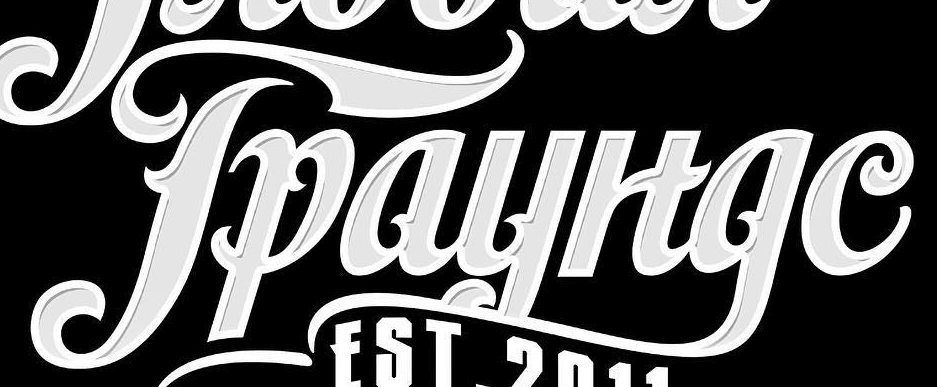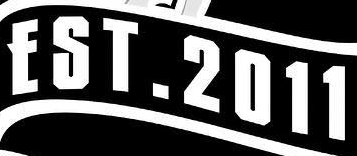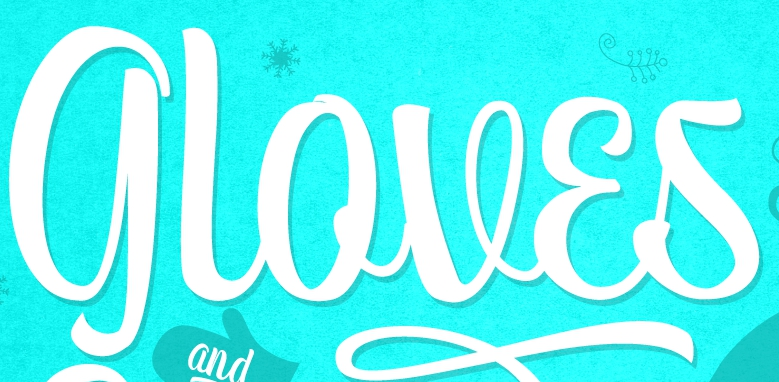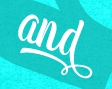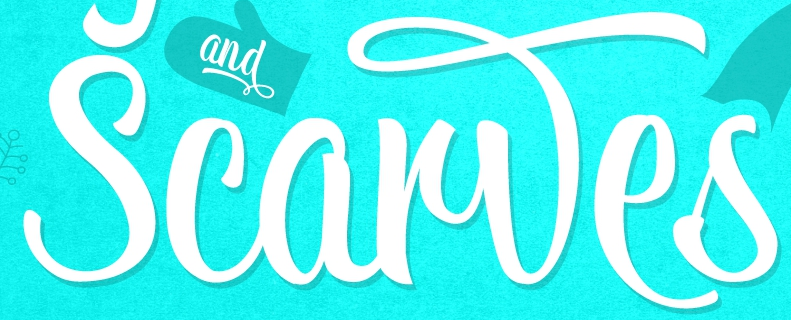Identify the words shown in these images in order, separated by a semicolon. Tpayltge; EST.2011; gloves; and; Scarwes 